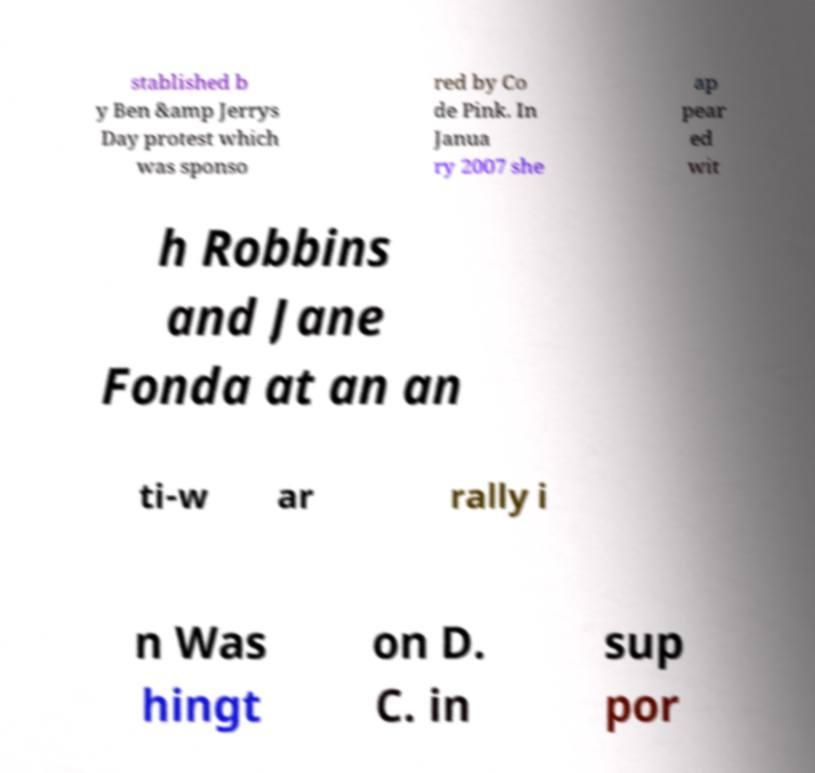Please identify and transcribe the text found in this image. stablished b y Ben &amp Jerrys Day protest which was sponso red by Co de Pink. In Janua ry 2007 she ap pear ed wit h Robbins and Jane Fonda at an an ti-w ar rally i n Was hingt on D. C. in sup por 